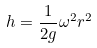<formula> <loc_0><loc_0><loc_500><loc_500>h = \frac { 1 } { 2 g } \omega ^ { 2 } r ^ { 2 }</formula> 